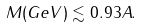Convert formula to latex. <formula><loc_0><loc_0><loc_500><loc_500>M ( G e V ) \lesssim 0 . 9 3 A .</formula> 